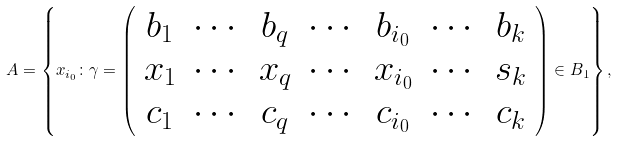Convert formula to latex. <formula><loc_0><loc_0><loc_500><loc_500>A = \left \{ x _ { i _ { 0 } } \colon \gamma = \left ( \begin{array} { c c c c c c c } b _ { 1 } & \cdots & b _ { q } & \cdots & b _ { i _ { 0 } } & \cdots & b _ { k } \\ x _ { 1 } & \cdots & x _ { q } & \cdots & x _ { i _ { 0 } } & \cdots & s _ { k } \\ c _ { 1 } & \cdots & c _ { q } & \cdots & c _ { i _ { 0 } } & \cdots & c _ { k } \\ \end{array} \right ) \in B _ { 1 } \right \} ,</formula> 